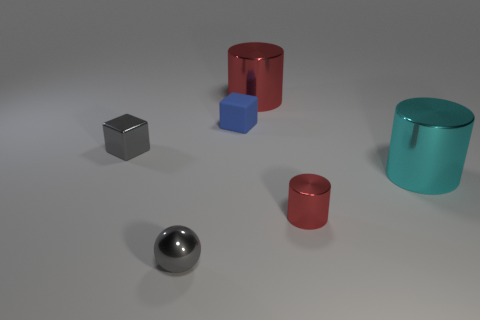How many tiny purple cylinders are there? Upon examining the image, there are no tiny purple cylinders present at all. 